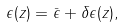Convert formula to latex. <formula><loc_0><loc_0><loc_500><loc_500>\epsilon ( z ) = \bar { \epsilon } + \delta \epsilon ( z ) ,</formula> 